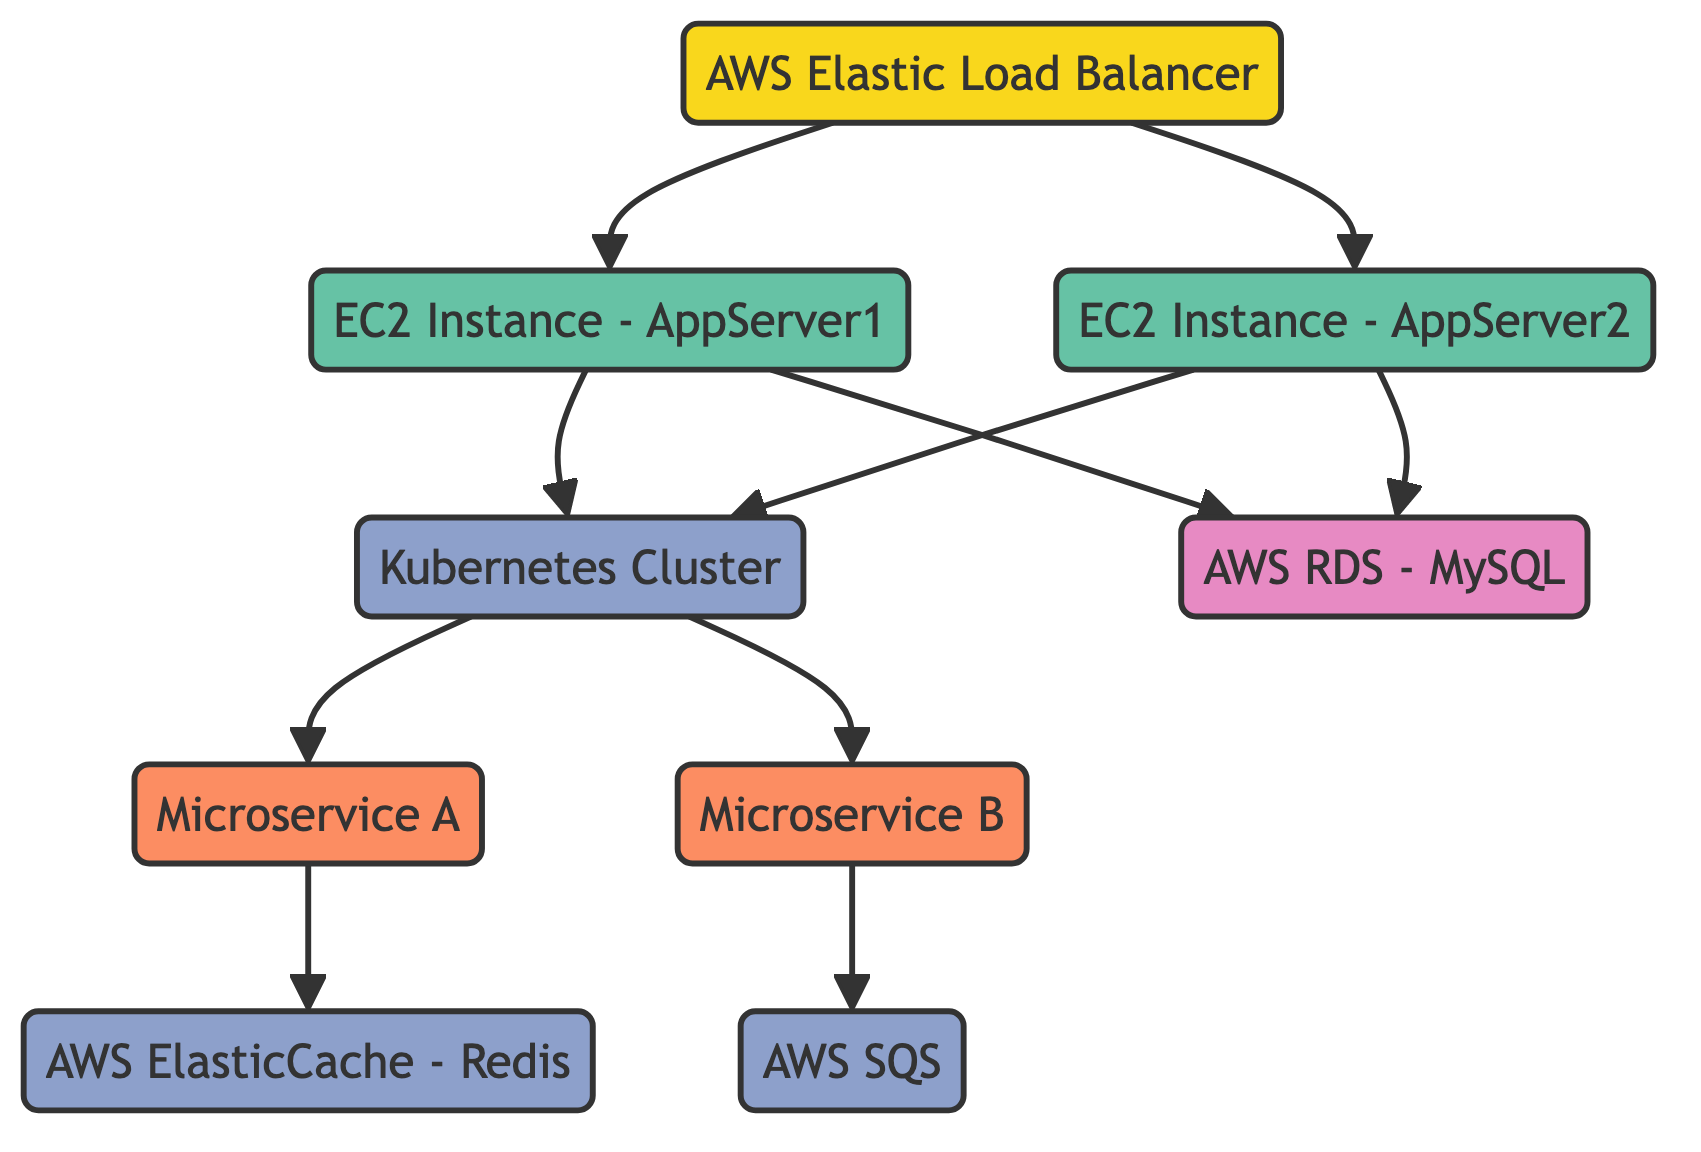What is the type of LoadBalancer? LoadBalancer is defined as a component in the nodes section of the data. This is deduced from the "type" attribute of the LoadBalancer node.
Answer: component How many virtual machines are in the diagram? The diagram includes two virtual machines, namely WebAppServer1 and WebAppServer2. This is counted from the nodes where the type is "virtualMachine."
Answer: 2 Which databases are used in the infrastructure? The only database present in the diagram is the AWS RDS - MySQL, as indicated in the nodes section where the type is specified as "database."
Answer: AWS RDS - MySQL Which services depend on AppService? AppService has two dependencies: MicroserviceA and MicroserviceB, which are listed under "dependencies" in the AppService node.
Answer: Microservice A, Microservice B What connection exists between WebAppServer1 and Database? WebAppServer1 has a direct connection to Database, which is represented by the arrow from WebAppServer1 to Database in the diagram. This indicates that WebAppServer1 relies on Database.
Answer: Direct connection Which component serves as the entry point for the web application? The AWS Elastic Load Balancer serves as the entry point, as it forwards traffic to the WebAppServer1 and WebAppServer2, shown by the connections in the diagram.
Answer: AWS Elastic Load Balancer What type of service is CacheService? CacheService is defined as a service in the nodes section of the data, which can be identified from the "type" attribute associated with CacheService.
Answer: service How many nodes are dependent on Database? There are two nodes that depend on Database: WebAppServer1 and WebAppServer2, as shown in their respective dependency lists. This counts the nodes that list Database in their "dependencies."
Answer: 2 Which node has the highest level of abstraction in this diagram? The node with the highest level of abstraction is LoadBalancer since it directly connects to other components without being dependent on any other node.
Answer: LoadBalancer 